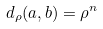<formula> <loc_0><loc_0><loc_500><loc_500>d _ { \rho } ( a , b ) = \rho ^ { n }</formula> 